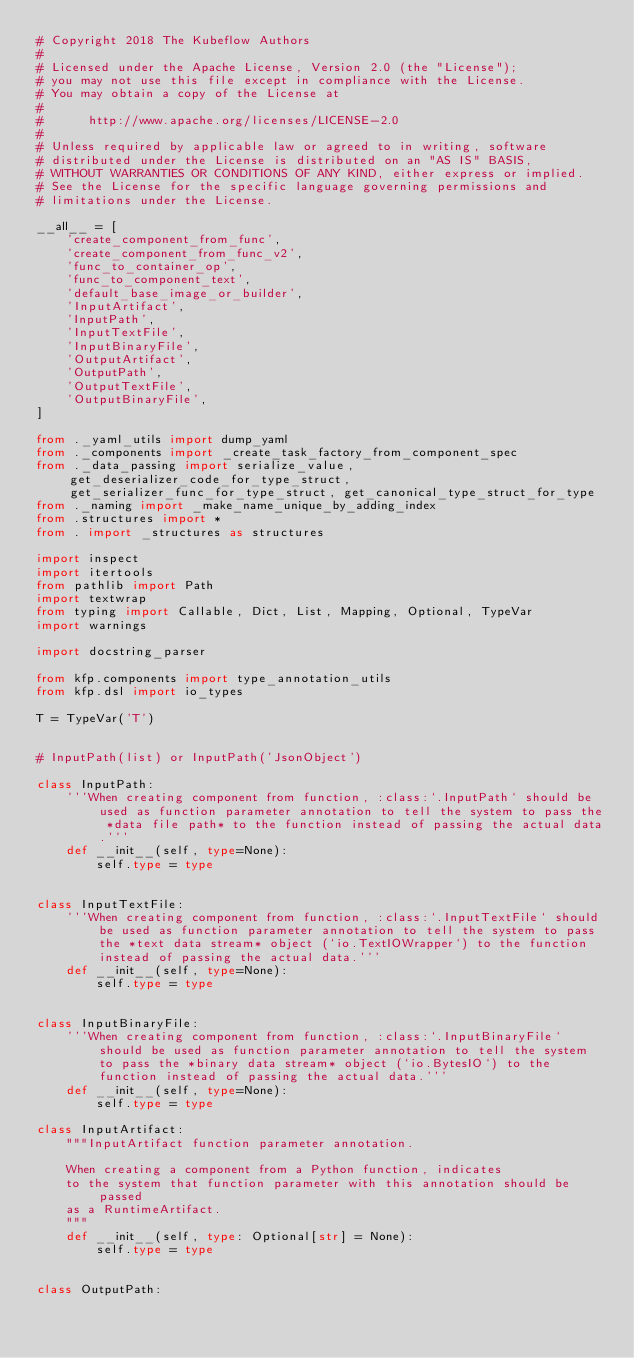Convert code to text. <code><loc_0><loc_0><loc_500><loc_500><_Python_># Copyright 2018 The Kubeflow Authors
#
# Licensed under the Apache License, Version 2.0 (the "License");
# you may not use this file except in compliance with the License.
# You may obtain a copy of the License at
#
#      http://www.apache.org/licenses/LICENSE-2.0
#
# Unless required by applicable law or agreed to in writing, software
# distributed under the License is distributed on an "AS IS" BASIS,
# WITHOUT WARRANTIES OR CONDITIONS OF ANY KIND, either express or implied.
# See the License for the specific language governing permissions and
# limitations under the License.

__all__ = [
    'create_component_from_func',
    'create_component_from_func_v2',
    'func_to_container_op',
    'func_to_component_text',
    'default_base_image_or_builder',
    'InputArtifact',
    'InputPath',
    'InputTextFile',
    'InputBinaryFile',
    'OutputArtifact',
    'OutputPath',
    'OutputTextFile',
    'OutputBinaryFile',
]

from ._yaml_utils import dump_yaml
from ._components import _create_task_factory_from_component_spec
from ._data_passing import serialize_value, get_deserializer_code_for_type_struct, get_serializer_func_for_type_struct, get_canonical_type_struct_for_type
from ._naming import _make_name_unique_by_adding_index
from .structures import *
from . import _structures as structures

import inspect
import itertools
from pathlib import Path
import textwrap
from typing import Callable, Dict, List, Mapping, Optional, TypeVar
import warnings

import docstring_parser

from kfp.components import type_annotation_utils
from kfp.dsl import io_types

T = TypeVar('T')


# InputPath(list) or InputPath('JsonObject')

class InputPath:
    '''When creating component from function, :class:`.InputPath` should be used as function parameter annotation to tell the system to pass the *data file path* to the function instead of passing the actual data.'''
    def __init__(self, type=None):
        self.type = type


class InputTextFile:
    '''When creating component from function, :class:`.InputTextFile` should be used as function parameter annotation to tell the system to pass the *text data stream* object (`io.TextIOWrapper`) to the function instead of passing the actual data.'''
    def __init__(self, type=None):
        self.type = type


class InputBinaryFile:
    '''When creating component from function, :class:`.InputBinaryFile` should be used as function parameter annotation to tell the system to pass the *binary data stream* object (`io.BytesIO`) to the function instead of passing the actual data.'''
    def __init__(self, type=None):
        self.type = type

class InputArtifact:
    """InputArtifact function parameter annotation.

    When creating a component from a Python function, indicates
    to the system that function parameter with this annotation should be passed
    as a RuntimeArtifact.
    """
    def __init__(self, type: Optional[str] = None):
        self.type = type


class OutputPath:</code> 